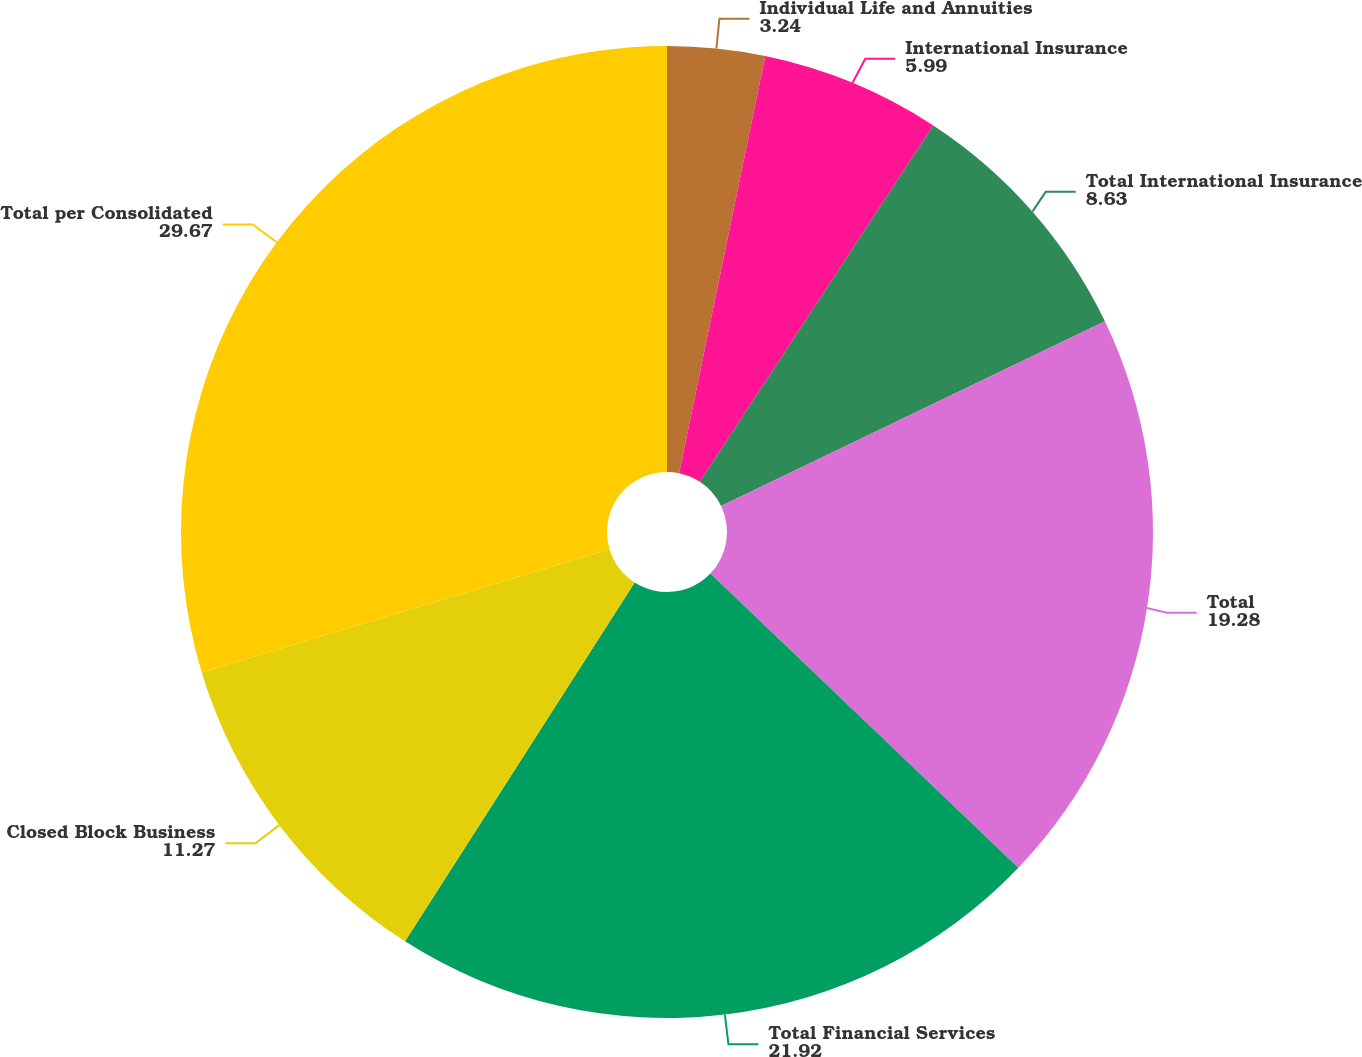Convert chart. <chart><loc_0><loc_0><loc_500><loc_500><pie_chart><fcel>Individual Life and Annuities<fcel>International Insurance<fcel>Total International Insurance<fcel>Total<fcel>Total Financial Services<fcel>Closed Block Business<fcel>Total per Consolidated<nl><fcel>3.24%<fcel>5.99%<fcel>8.63%<fcel>19.28%<fcel>21.92%<fcel>11.27%<fcel>29.67%<nl></chart> 